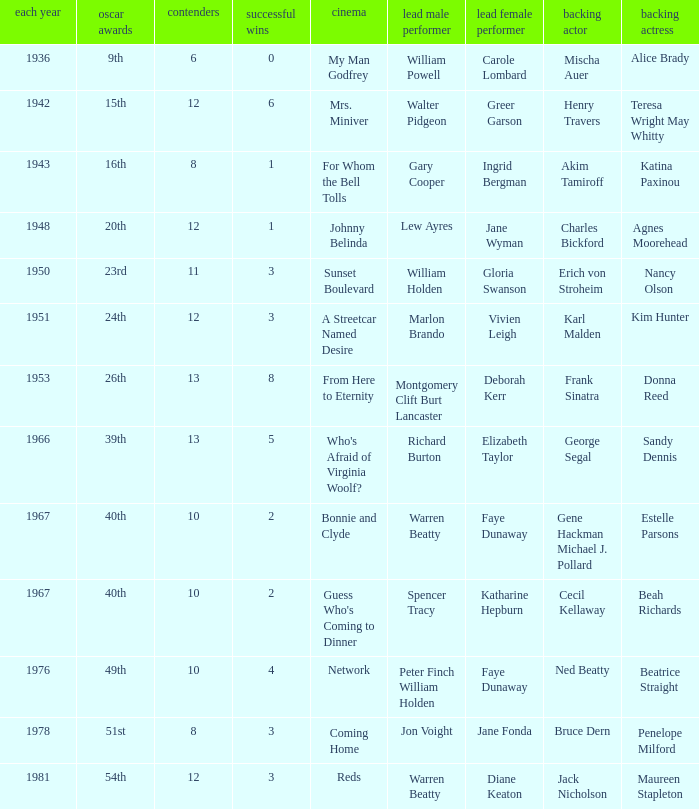Who was the leading actress in a film with Warren Beatty as the leading actor and also at the 40th Oscars? Faye Dunaway. 